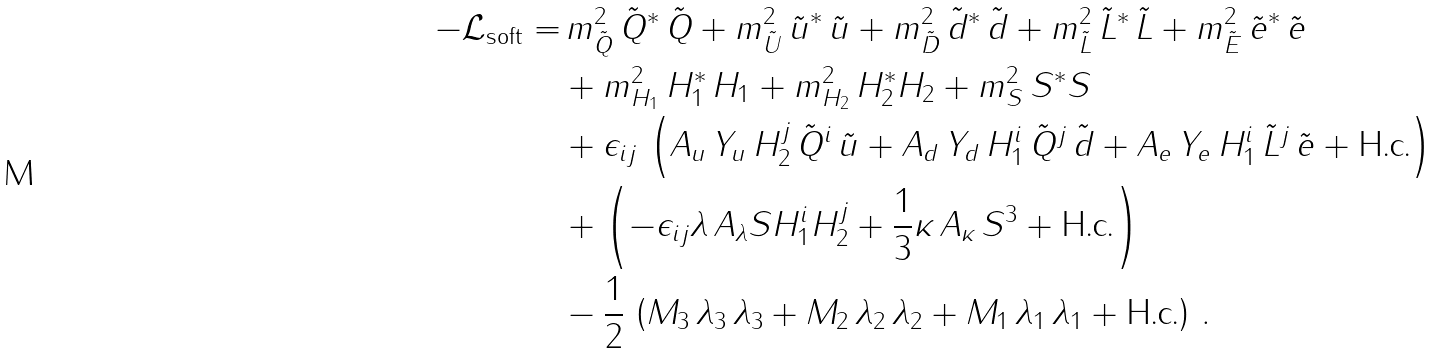Convert formula to latex. <formula><loc_0><loc_0><loc_500><loc_500>- \mathcal { L } _ { \text {soft} } = & \, { m ^ { 2 } _ { \tilde { Q } } } \, \tilde { Q } ^ { * } \, \tilde { Q } + { m ^ { 2 } _ { \tilde { U } } } \, \tilde { u } ^ { * } \, \tilde { u } + { m ^ { 2 } _ { \tilde { D } } } \, \tilde { d } ^ { * } \, \tilde { d } + { m ^ { 2 } _ { \tilde { L } } } \, \tilde { L } ^ { * } \, \tilde { L } + { m ^ { 2 } _ { \tilde { E } } } \, \tilde { e } ^ { * } \, \tilde { e } \\ & + m _ { H _ { 1 } } ^ { 2 } \, H _ { 1 } ^ { * } \, H _ { 1 } + m _ { H _ { 2 } } ^ { 2 } \, H _ { 2 } ^ { * } H _ { 2 } + m _ { S } ^ { 2 } \, S ^ { * } S \\ & + \epsilon _ { i j } \, \left ( A _ { u } \, Y _ { u } \, H _ { 2 } ^ { j } \, \tilde { Q } ^ { i } \, \tilde { u } + A _ { d } \, Y _ { d } \, H _ { 1 } ^ { i } \, \tilde { Q } ^ { j } \, \tilde { d } + A _ { e } \, Y _ { e } \, H _ { 1 } ^ { i } \, \tilde { L } ^ { j } \, \tilde { e } + \text {H.c.} \right ) \\ & + \left ( - \epsilon _ { i j } \lambda \, A _ { \lambda } S H _ { 1 } ^ { i } H _ { 2 } ^ { j } + \frac { 1 } { 3 } \kappa \, A _ { \kappa } \, S ^ { 3 } + \text {H.c.} \right ) \\ & - \frac { 1 } { 2 } \, \left ( M _ { 3 } \, \lambda _ { 3 } \, \lambda _ { 3 } + M _ { 2 } \, \lambda _ { 2 } \, \lambda _ { 2 } + M _ { 1 } \, \lambda _ { 1 } \, \lambda _ { 1 } + \text {H.c.} \right ) \, .</formula> 